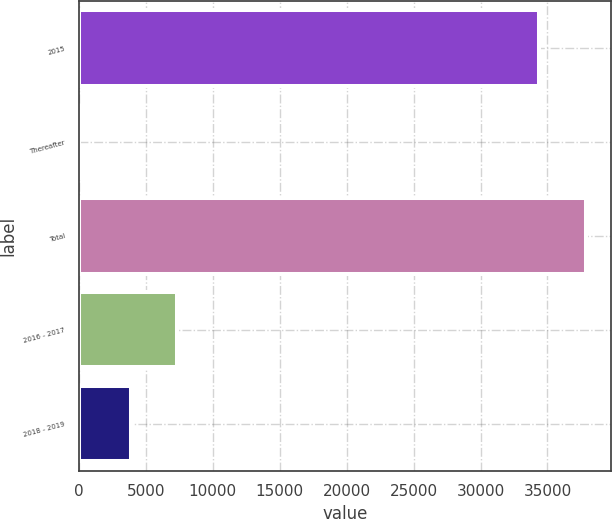<chart> <loc_0><loc_0><loc_500><loc_500><bar_chart><fcel>2015<fcel>Thereafter<fcel>Total<fcel>2016 - 2017<fcel>2018 - 2019<nl><fcel>34401<fcel>3.5<fcel>37840.8<fcel>7319.75<fcel>3880<nl></chart> 